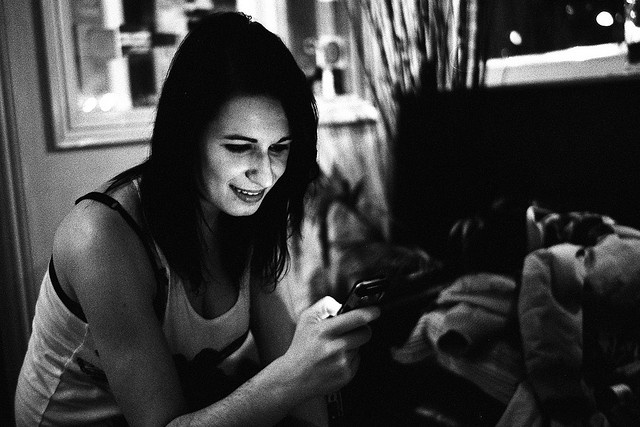Describe the objects in this image and their specific colors. I can see people in black, gray, darkgray, and lightgray tones, couch in black and gray tones, and cell phone in black, gray, darkgray, and lightgray tones in this image. 